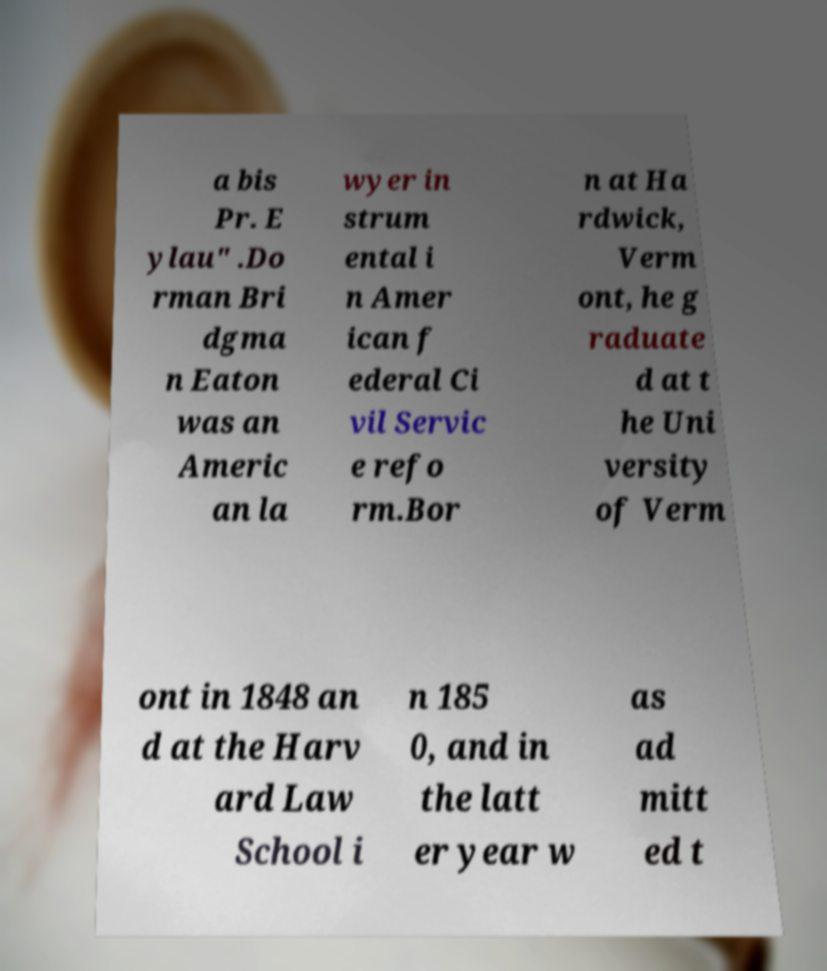Can you accurately transcribe the text from the provided image for me? a bis Pr. E ylau" .Do rman Bri dgma n Eaton was an Americ an la wyer in strum ental i n Amer ican f ederal Ci vil Servic e refo rm.Bor n at Ha rdwick, Verm ont, he g raduate d at t he Uni versity of Verm ont in 1848 an d at the Harv ard Law School i n 185 0, and in the latt er year w as ad mitt ed t 